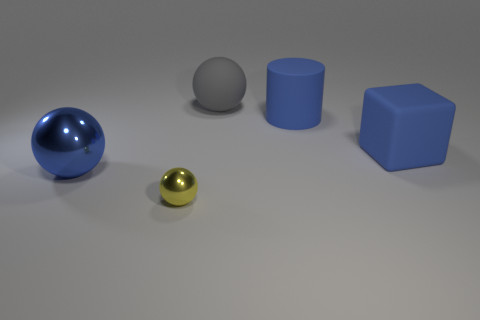Is there any other thing that is the same size as the gray rubber thing?
Provide a succinct answer. Yes. What number of blue rubber things are the same size as the blue shiny sphere?
Ensure brevity in your answer.  2. Are there fewer yellow objects that are behind the big gray ball than blue blocks in front of the large blue rubber cube?
Ensure brevity in your answer.  No. How many shiny things are either large brown cubes or gray spheres?
Your response must be concise. 0. There is a large gray matte thing; what shape is it?
Keep it short and to the point. Sphere. What material is the cylinder that is the same size as the rubber cube?
Offer a terse response. Rubber. What number of large things are either yellow metallic balls or blue matte things?
Provide a succinct answer. 2. Are any purple shiny cylinders visible?
Offer a very short reply. No. The thing that is made of the same material as the large blue ball is what size?
Your response must be concise. Small. Are the big gray sphere and the small yellow object made of the same material?
Keep it short and to the point. No. 